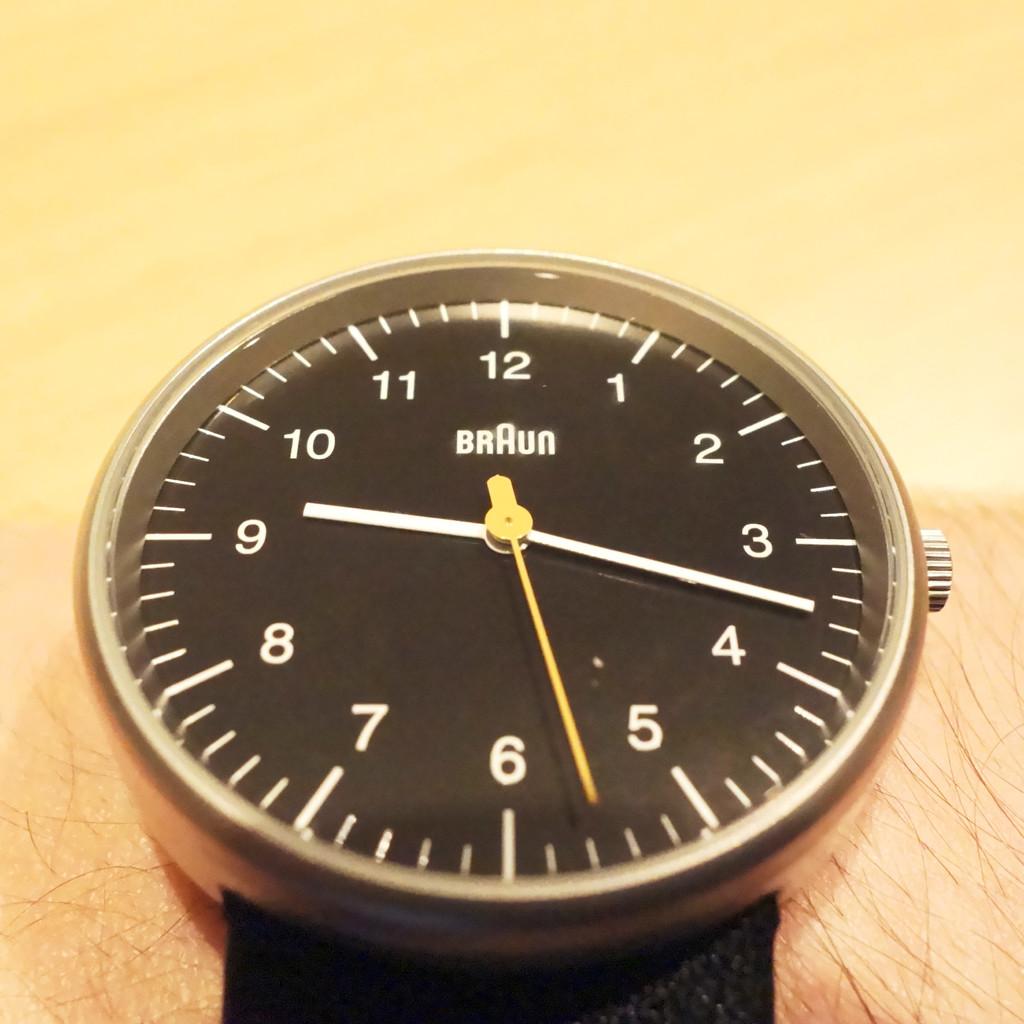What is the brand of the watch?
Ensure brevity in your answer.  Braun. What time is it?
Offer a terse response. 9:17. 